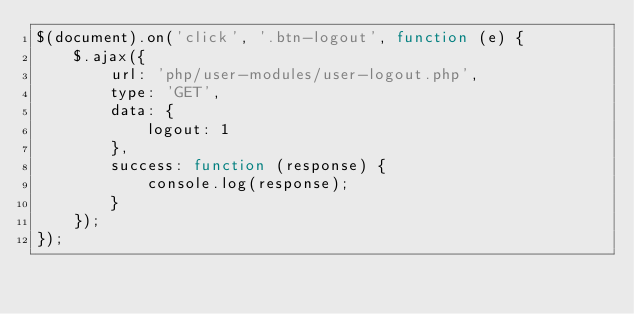<code> <loc_0><loc_0><loc_500><loc_500><_JavaScript_>$(document).on('click', '.btn-logout', function (e) {
    $.ajax({
        url: 'php/user-modules/user-logout.php',
        type: 'GET',
        data: {
            logout: 1
        },
        success: function (response) {
            console.log(response);
        }
    });
});</code> 